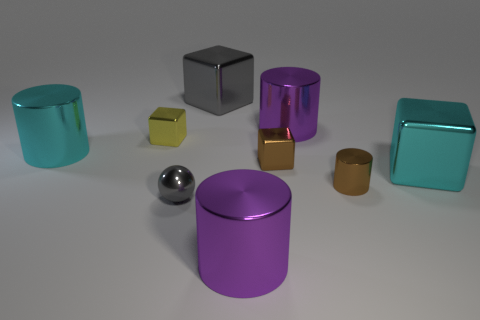Subtract all brown metal blocks. How many blocks are left? 3 Add 1 small blue metallic cubes. How many objects exist? 10 Subtract 1 spheres. How many spheres are left? 0 Subtract all cylinders. How many objects are left? 5 Subtract all gray cubes. How many purple cylinders are left? 2 Subtract all big cyan cylinders. Subtract all purple objects. How many objects are left? 6 Add 5 tiny cylinders. How many tiny cylinders are left? 6 Add 1 tiny things. How many tiny things exist? 5 Subtract all brown cylinders. How many cylinders are left? 3 Subtract 1 brown cylinders. How many objects are left? 8 